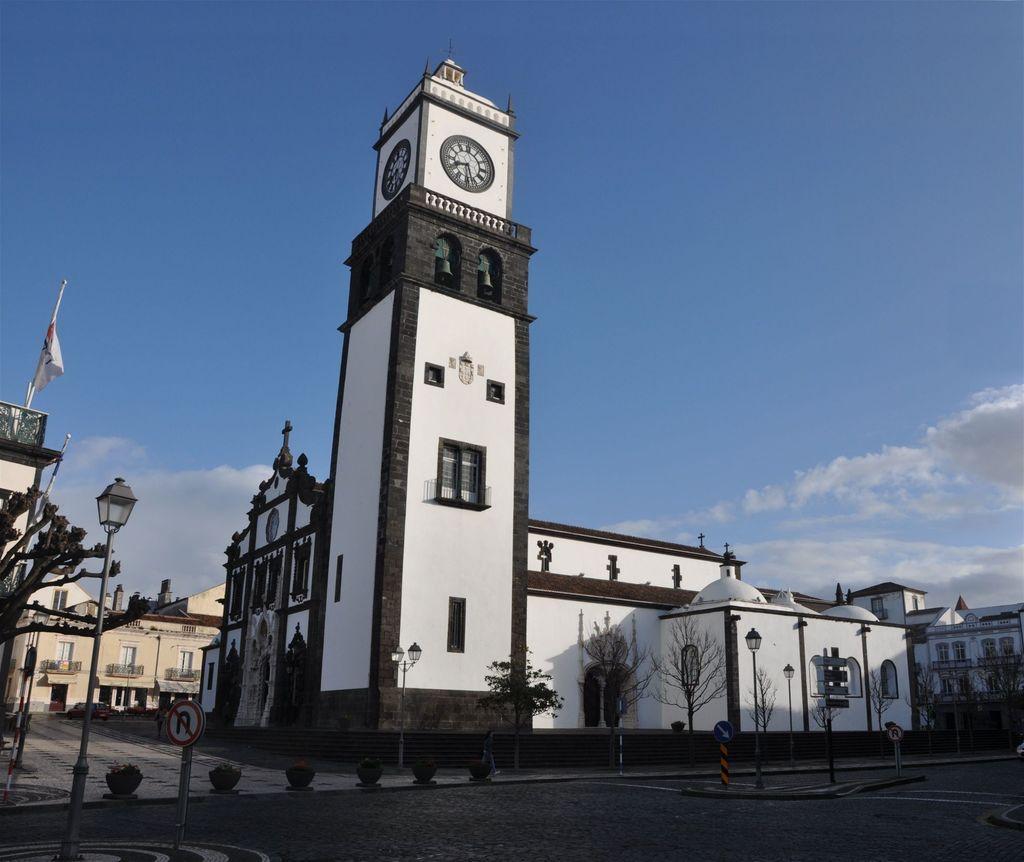Could you give a brief overview of what you see in this image? In this picture I can see the road at the bottom, in the middle there are trees, lamps and buildings. At the top there is the sky, I can see a sign board on the left side. 